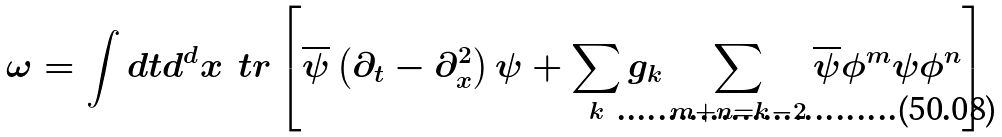Convert formula to latex. <formula><loc_0><loc_0><loc_500><loc_500>\omega = \int d t d ^ { d } x \, \ t r \left [ \overline { \psi } \left ( \partial _ { t } - \partial ^ { 2 } _ { x } \right ) \psi + \sum _ { k } g _ { k } \sum _ { m + n = k - 2 } \overline { \psi } \phi ^ { m } \psi \phi ^ { n } \right ]</formula> 